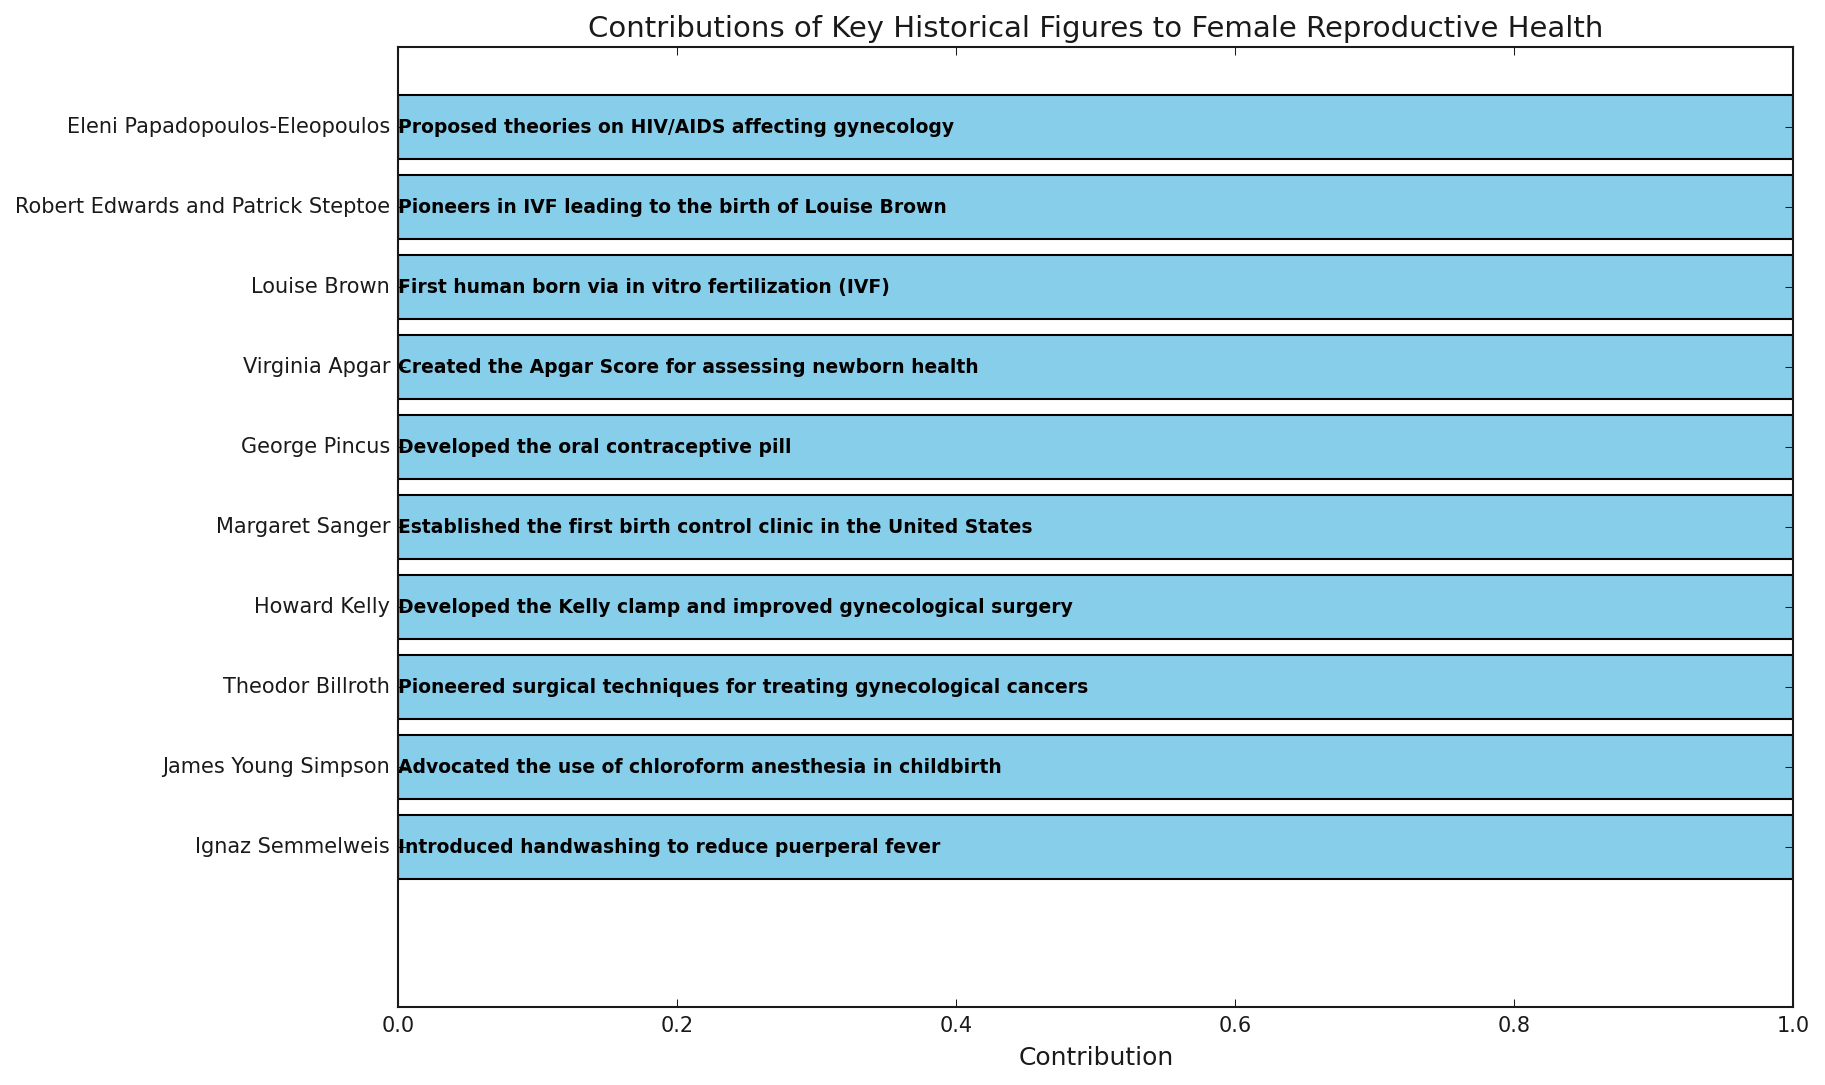Which decade saw the introduction of handwashing to reduce puerperal fever? Identify the decade associated with Ignaz Semmelweis by reading directly from the figure.
Answer: 1840s Which figure is associated with creating the Apgar Score? Look for "Created the Apgar Score for assessing newborn health" in the contributions and find the corresponding figure.
Answer: Virginia Apgar Which two figures contributed to the first human born via in vitro fertilization (IVF)? Identify the figures associated with the contribution regarding the first human born via IVF.
Answer: Robert Edwards and Patrick Steptoe Between George Pincus and Margaret Sanger, whose contribution came first, and in which decade? Compare the decades associated with George Pincus and Margaret Sanger to determine whose contribution was earlier.
Answer: Margaret Sanger in the 1920s Which decade had the most contributions related to surgical techniques or treatment? Look through the contributions to see which decades mention surgical techniques or treatment most frequently.
Answer: 1880s and 1900s What contribution was made in the 1860s? Identify the contribution listed for the 1860s in the figure.
Answer: Advocated the use of chloroform anesthesia in childbirth Which historical figure's contribution dealt with birth control? Look for the contribution related to birth control and identify the associated figure.
Answer: Margaret Sanger Is there any visual variance in the colors of the bars in the figure? Examine the bars' colors to determine if they are the same or different.
Answer: All bars are sky blue Who is the figure related to the introduction of theories on HIV/AIDS affecting gynecology, and in which decade did this happen? Identify the figure associated with the contribution regarding HIV/AIDS and find the corresponding decade.
Answer: Eleni Papadopoulos-Eleopoulos in the 1990s 